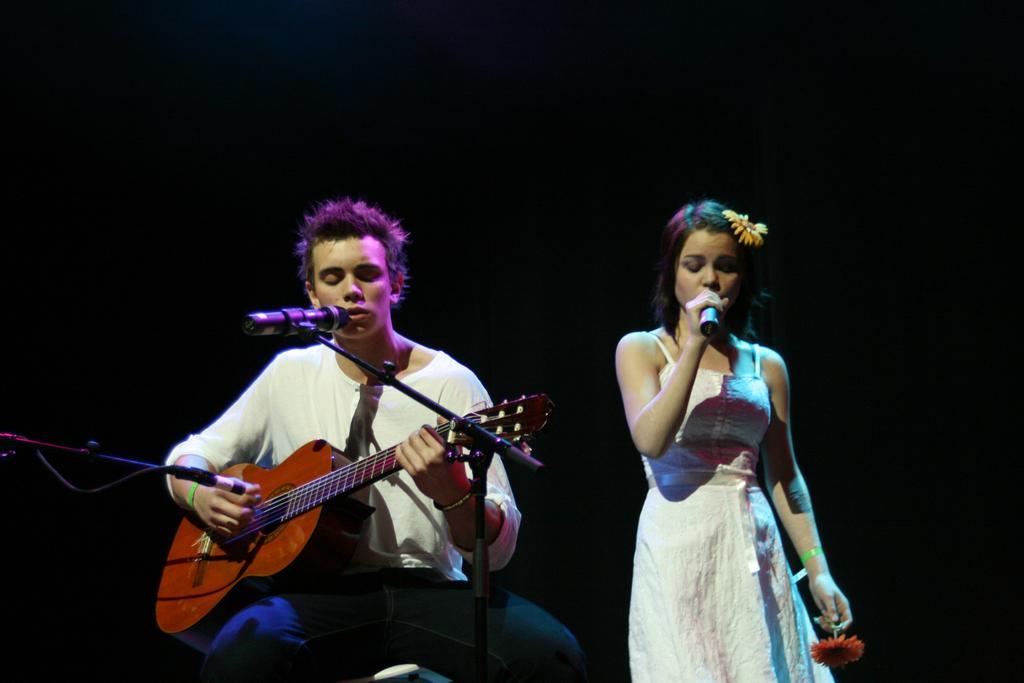Please provide a concise description of this image. This image is clicked in a musical concert. here there are two persons on man and woman,man is sitting and woman is standing. man is singing something a mic is in front of him, he is also playing a guitar. woman is holding a flower she also has a flower on head. she is also singing something. man is wearing white shirt and blue pant, women is wearing white gown. 